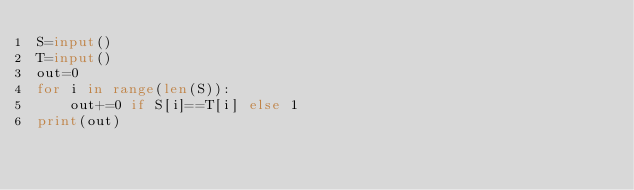<code> <loc_0><loc_0><loc_500><loc_500><_Python_>S=input()
T=input()
out=0
for i in range(len(S)):
    out+=0 if S[i]==T[i] else 1
print(out)</code> 